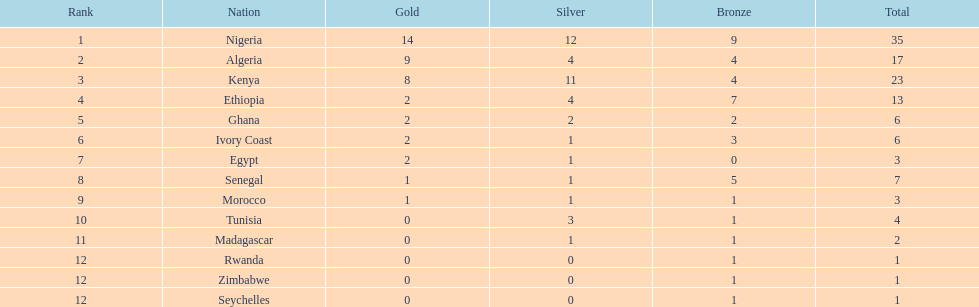What is the name of the only nation that did not earn any bronze medals? Egypt. 